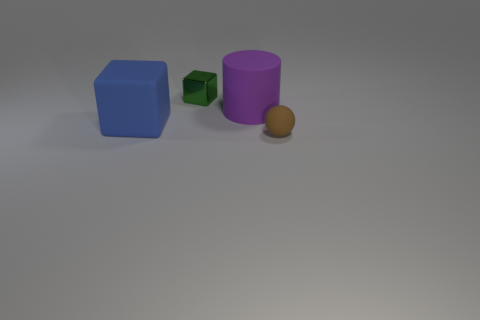What number of metal things are big blue blocks or tiny yellow balls?
Offer a terse response. 0. What material is the large object behind the block left of the green cube made of?
Keep it short and to the point. Rubber. Are there more tiny things behind the purple matte cylinder than blue blocks?
Offer a very short reply. No. Is there another purple cylinder that has the same material as the large purple cylinder?
Offer a very short reply. No. There is a tiny thing behind the sphere; does it have the same shape as the brown rubber thing?
Your answer should be very brief. No. There is a object on the left side of the small object behind the tiny matte ball; what number of large things are behind it?
Your response must be concise. 1. Are there fewer purple cylinders that are in front of the cylinder than big blue cubes that are behind the metallic cube?
Provide a short and direct response. No. There is another small thing that is the same shape as the blue rubber object; what is its color?
Provide a short and direct response. Green. How big is the brown matte object?
Your response must be concise. Small. What number of cubes have the same size as the purple rubber cylinder?
Make the answer very short. 1. 